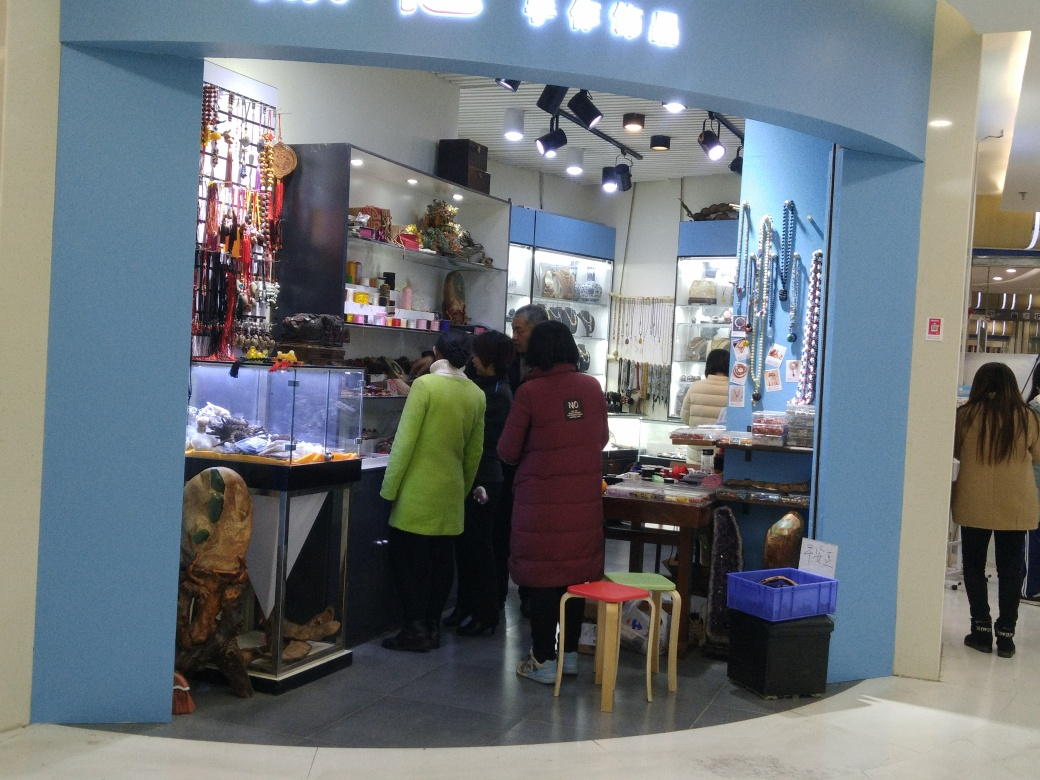Can you describe the atmosphere of the place where this shop is located? The shop is situated in a brightly lit indoor space, possibly within a mall or a specialized market area. The environment looks clean and well-organized, with a calm atmosphere suggested by the unhurried posture of the customers browsing the goods. 